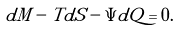<formula> <loc_0><loc_0><loc_500><loc_500>d M - T d S - \Psi d Q = 0 .</formula> 